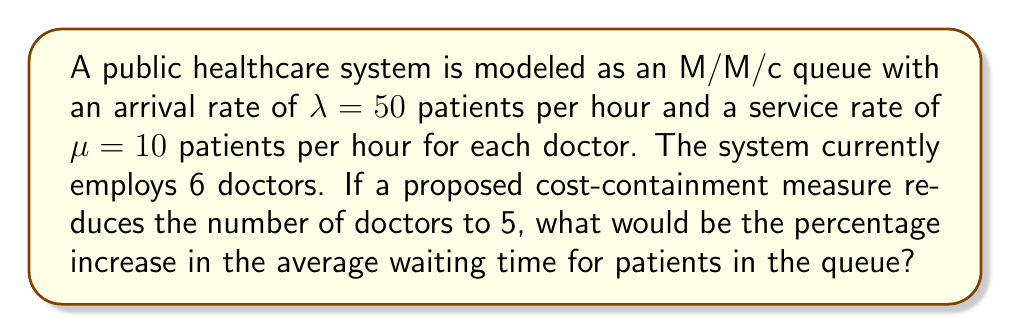Show me your answer to this math problem. To solve this problem, we'll use the M/M/c queueing model and follow these steps:

1. Calculate the current average waiting time (W_q) with 6 doctors
2. Calculate the new average waiting time with 5 doctors
3. Compute the percentage increase

Step 1: Current average waiting time (6 doctors)

The utilization factor $\rho = \frac{\lambda}{c\mu} = \frac{50}{6 \cdot 10} = \frac{5}{6} \approx 0.833$

For an M/M/c queue, the average waiting time in the queue is given by:

$$W_q = \frac{P_0 \cdot (c\rho)^c}{c! \cdot c\mu \cdot (1-\rho)^2} \cdot \frac{1}{\sum_{n=0}^{c-1} \frac{(c\rho)^n}{n!} + \frac{(c\rho)^c}{c!(1-\rho)}}$$

Where $P_0$ is the probability of an empty system:

$$P_0 = \left[\sum_{n=0}^{c-1} \frac{(c\rho)^n}{n!} + \frac{(c\rho)^c}{c!(1-\rho)}\right]^{-1}$$

Calculating $P_0$ and $W_q$ for 6 doctors:

$P_0 \approx 0.00248$
$W_q \approx 0.0992$ hours or 5.95 minutes

Step 2: New average waiting time (5 doctors)

New utilization factor: $\rho_{new} = \frac{50}{5 \cdot 10} = 1$

When $\rho = 1$, the system is unstable, and the queue will grow indefinitely. The average waiting time approaches infinity.

Step 3: Percentage increase

Since the new waiting time approaches infinity, the percentage increase is effectively infinite.
Answer: The percentage increase in average waiting time is infinite. 